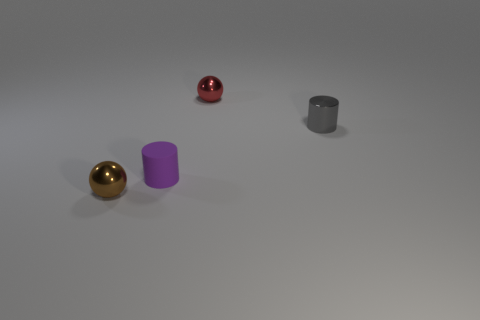The other thing that is the same shape as the brown metallic thing is what size?
Offer a very short reply. Small. Are there any rubber cylinders on the left side of the purple rubber cylinder?
Keep it short and to the point. No. Are there an equal number of small red metal objects that are to the left of the small purple cylinder and small blue rubber cylinders?
Ensure brevity in your answer.  Yes. Is there a brown ball that is on the left side of the metallic object that is to the left of the metal ball that is to the right of the rubber object?
Your answer should be very brief. No. What is the material of the small red sphere?
Offer a terse response. Metal. How many other things are there of the same shape as the brown object?
Give a very brief answer. 1. Is the red metal thing the same shape as the brown thing?
Your answer should be compact. Yes. How many things are tiny things behind the small brown shiny object or metal balls in front of the tiny purple rubber cylinder?
Offer a very short reply. 4. How many objects are blue matte balls or gray cylinders?
Keep it short and to the point. 1. What number of metallic cylinders are on the left side of the thing behind the gray thing?
Give a very brief answer. 0. 